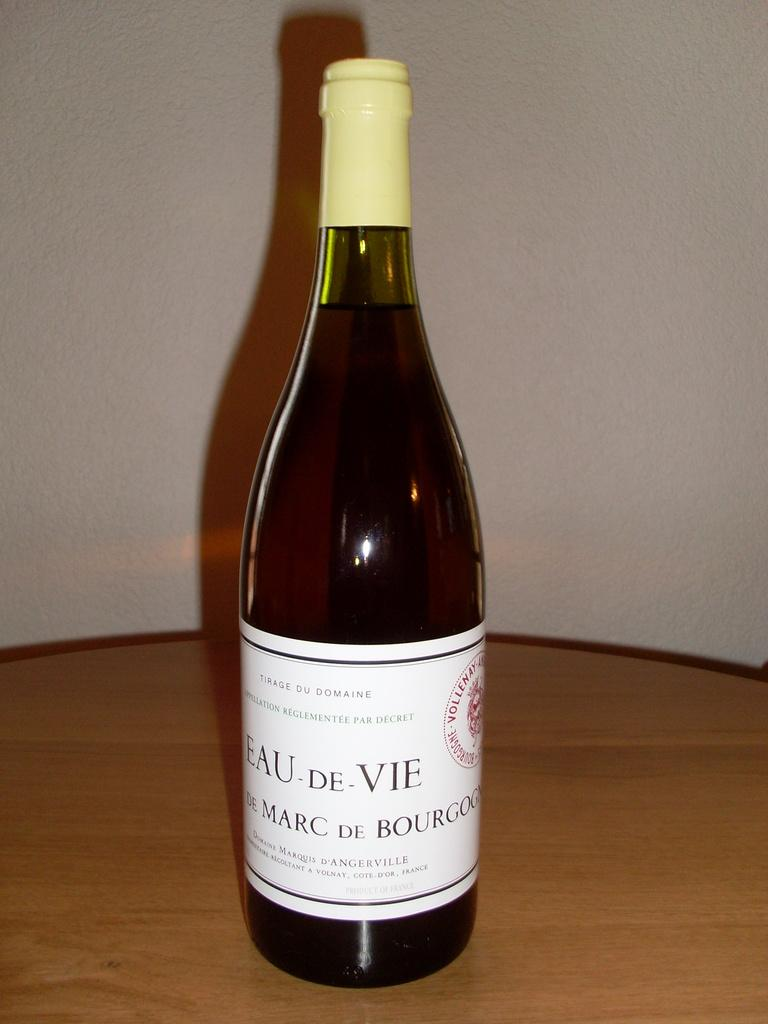<image>
Relay a brief, clear account of the picture shown. A bottle of Eau De Vie sits on the table in a bottle 